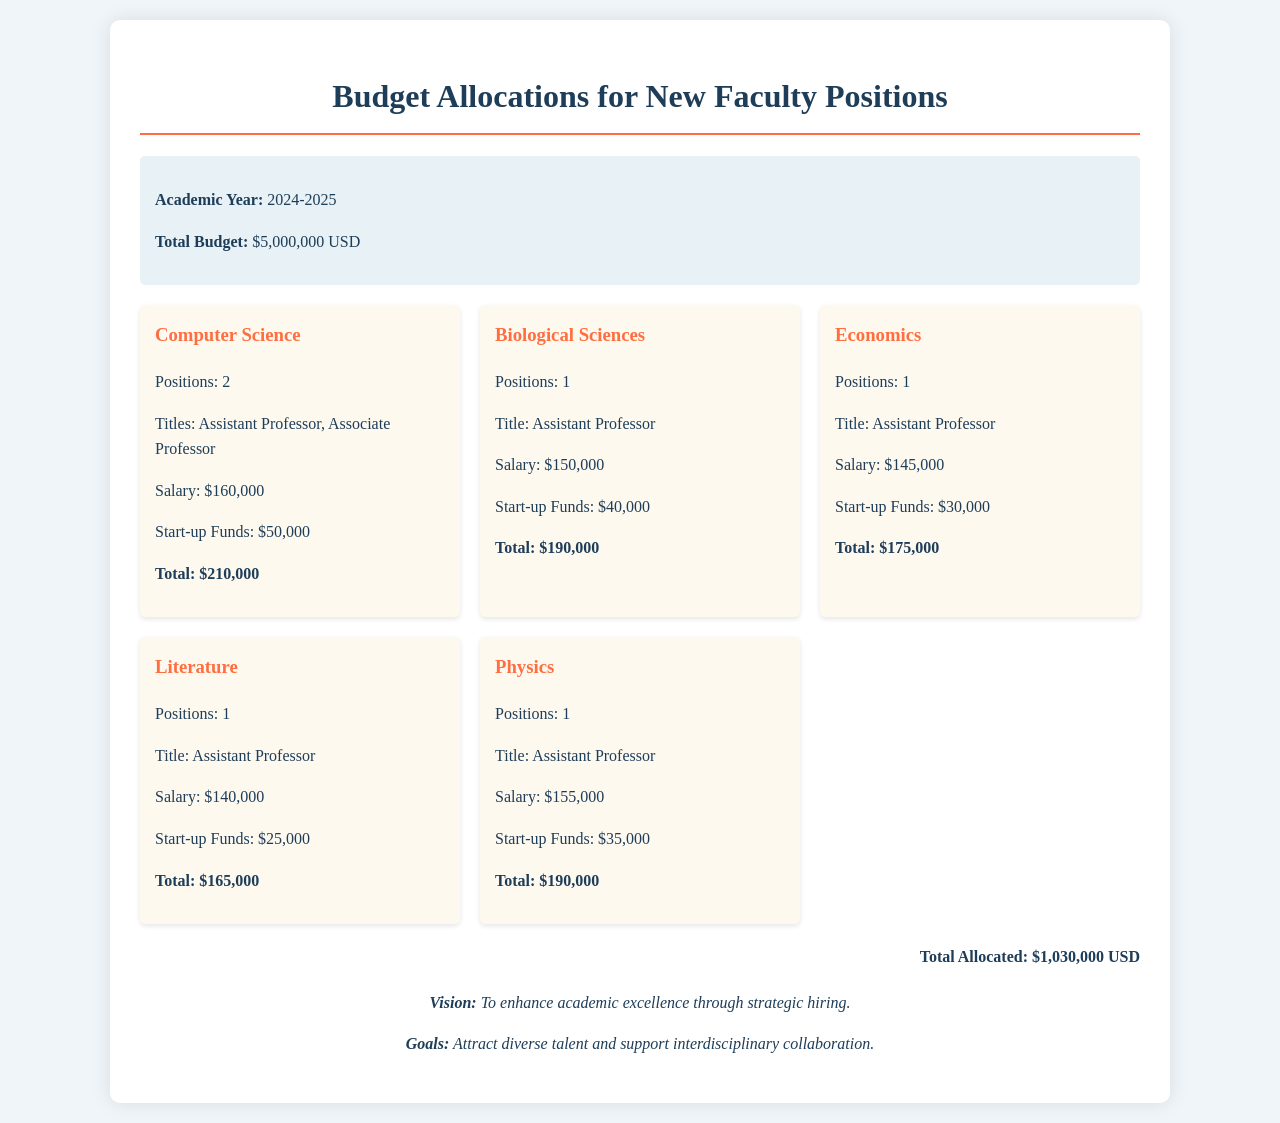What is the academic year for the budget allocations? The academic year mentioned in the document is stated clearly in the budget summary section.
Answer: 2024-2025 What is the total budget for new faculty positions? The total budget for the new faculty positions is provided in the budget summary section.
Answer: $5,000,000 USD How many positions are allocated for the Computer Science department? The number of positions for each department is listed under the respective department cards.
Answer: 2 What is the total allocated amount for the Biological Sciences department? The total for each department is noted in the respective department cards, which includes salaries and start-up funds.
Answer: $190,000 What title is assigned to the new position in the Economics department? The title of the position is mentioned in the department card for Economics.
Answer: Assistant Professor What is the salary for the position in the Physics department? The salary for each position is detailed in the individual department cards.
Answer: $155,000 How much are the start-up funds for the Literature department? The start-up funds allocated for each department are shown in the department cards.
Answer: $25,000 What is the total allocated budget across all departments? The total allocated amount is provided at the bottom of the document in the total allocated section.
Answer: $1,030,000 USD What is the vision stated in the document? The vision is mentioned in the remarks section of the document.
Answer: To enhance academic excellence through strategic hiring 